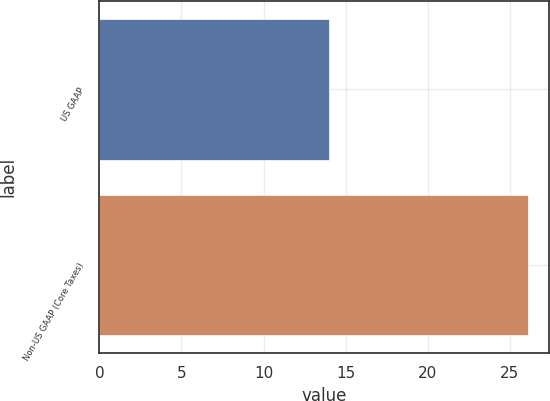<chart> <loc_0><loc_0><loc_500><loc_500><bar_chart><fcel>US GAAP<fcel>Non-US GAAP (Core Taxes)<nl><fcel>14<fcel>26.1<nl></chart> 